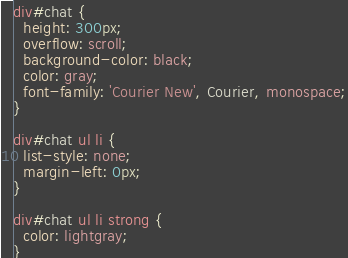Convert code to text. <code><loc_0><loc_0><loc_500><loc_500><_CSS_>div#chat {
  height: 300px;
  overflow: scroll;
  background-color: black;
  color: gray;
  font-family: 'Courier New', Courier, monospace;
}

div#chat ul li {
  list-style: none;
  margin-left: 0px;
}

div#chat ul li strong {
  color: lightgray;
}

</code> 